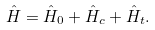Convert formula to latex. <formula><loc_0><loc_0><loc_500><loc_500>\hat { H } = \hat { H } _ { 0 } + \hat { H } _ { c } + \hat { H } _ { t } .</formula> 